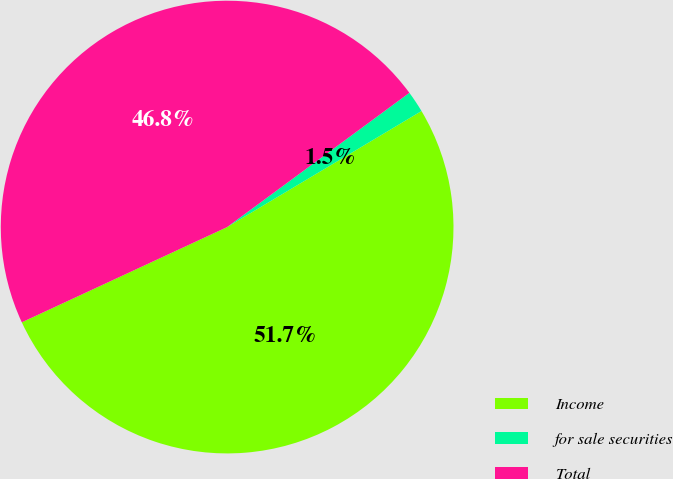Convert chart. <chart><loc_0><loc_0><loc_500><loc_500><pie_chart><fcel>Income<fcel>for sale securities<fcel>Total<nl><fcel>51.65%<fcel>1.54%<fcel>46.8%<nl></chart> 